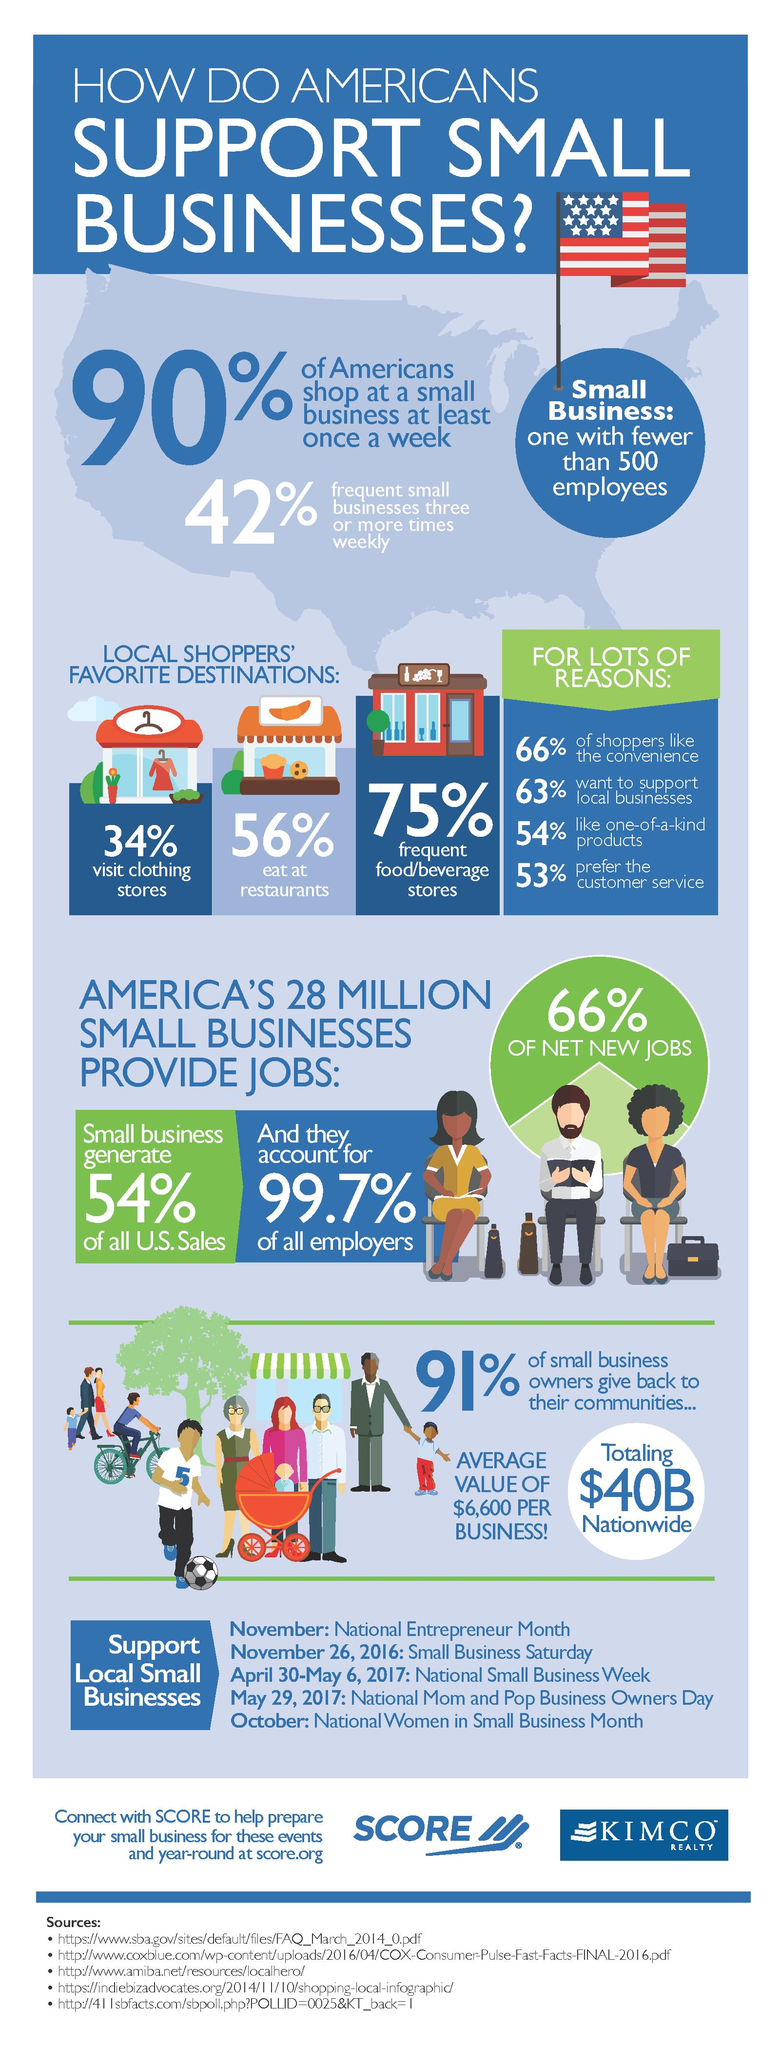Identify some key points in this picture. According to a recent survey, 37% of Americans are willing to support local businesses. According to a survey, approximately 34% of American shoppers do not prioritize the convenience of shopping. According to a recent survey, it was found that 44% of Americans do not like to eat at restaurants. According to a recent survey, a staggering 75% of Americans visit food and beverage shops frequently. According to a recent study, a staggering 91% of money earned through small businesses is being reinvested back into society for the betterment of all. 